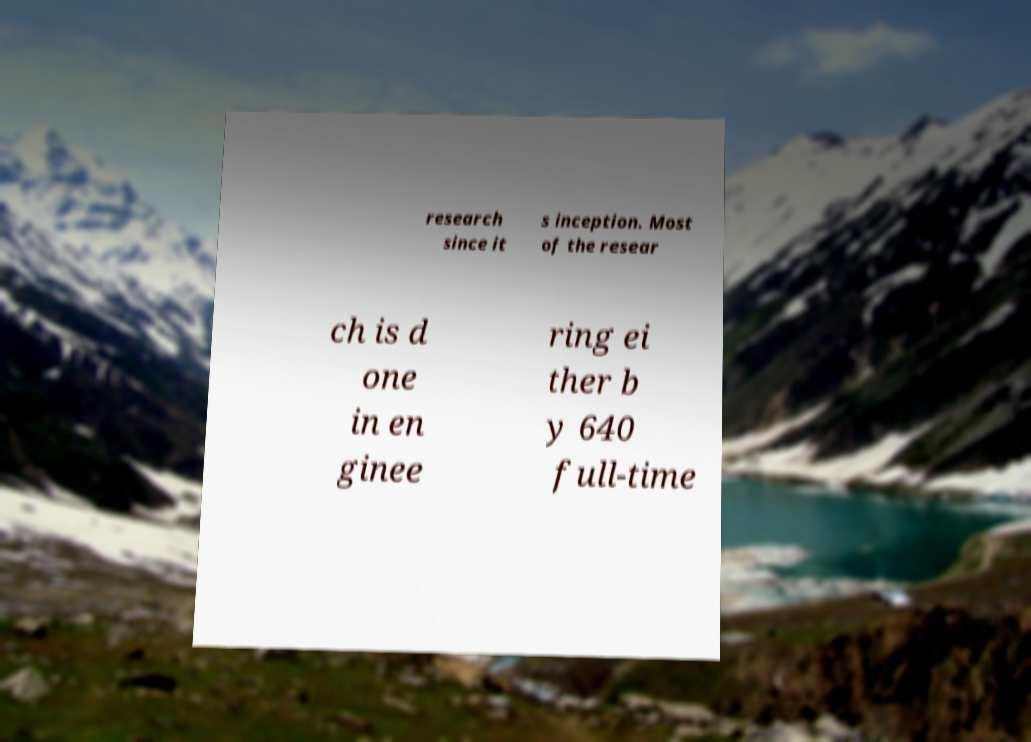There's text embedded in this image that I need extracted. Can you transcribe it verbatim? research since it s inception. Most of the resear ch is d one in en ginee ring ei ther b y 640 full-time 